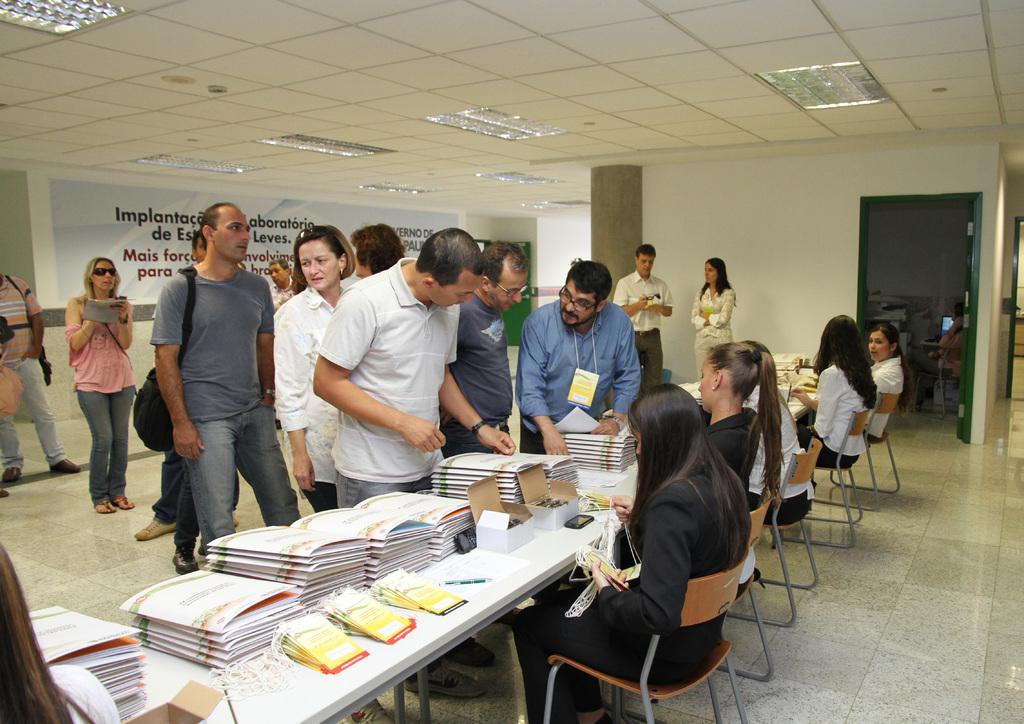Please provide a concise description of this image. In the image we can see there are people who are standing and in front of them there are woman who are sitting on chair and on the table there are books kept. 